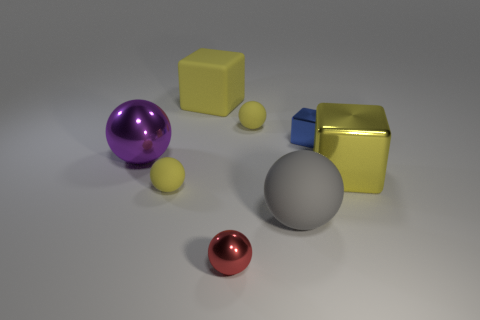Subtract all red balls. How many balls are left? 4 Subtract 2 spheres. How many spheres are left? 3 Subtract all purple spheres. How many spheres are left? 4 Subtract all cyan balls. Subtract all purple cylinders. How many balls are left? 5 Add 1 blocks. How many objects exist? 9 Subtract all balls. How many objects are left? 3 Add 7 small yellow things. How many small yellow things are left? 9 Add 5 tiny cubes. How many tiny cubes exist? 6 Subtract 0 brown cylinders. How many objects are left? 8 Subtract all green spheres. Subtract all yellow balls. How many objects are left? 6 